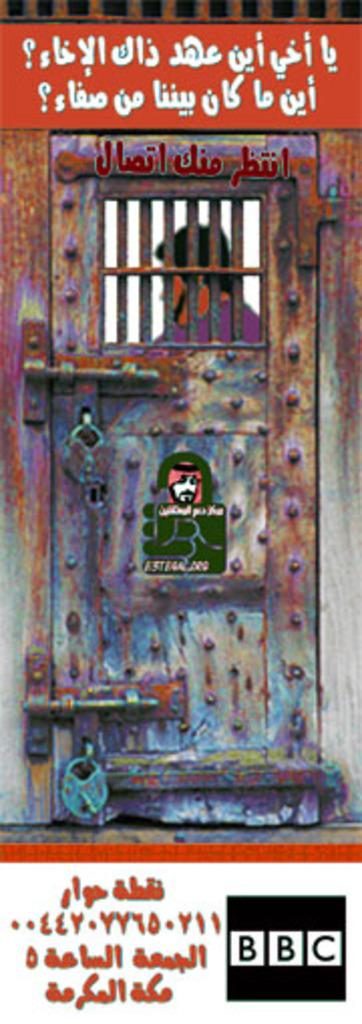<image>
Create a compact narrative representing the image presented. a photo of a locked cell with the letts BBC in black at the bottom right 